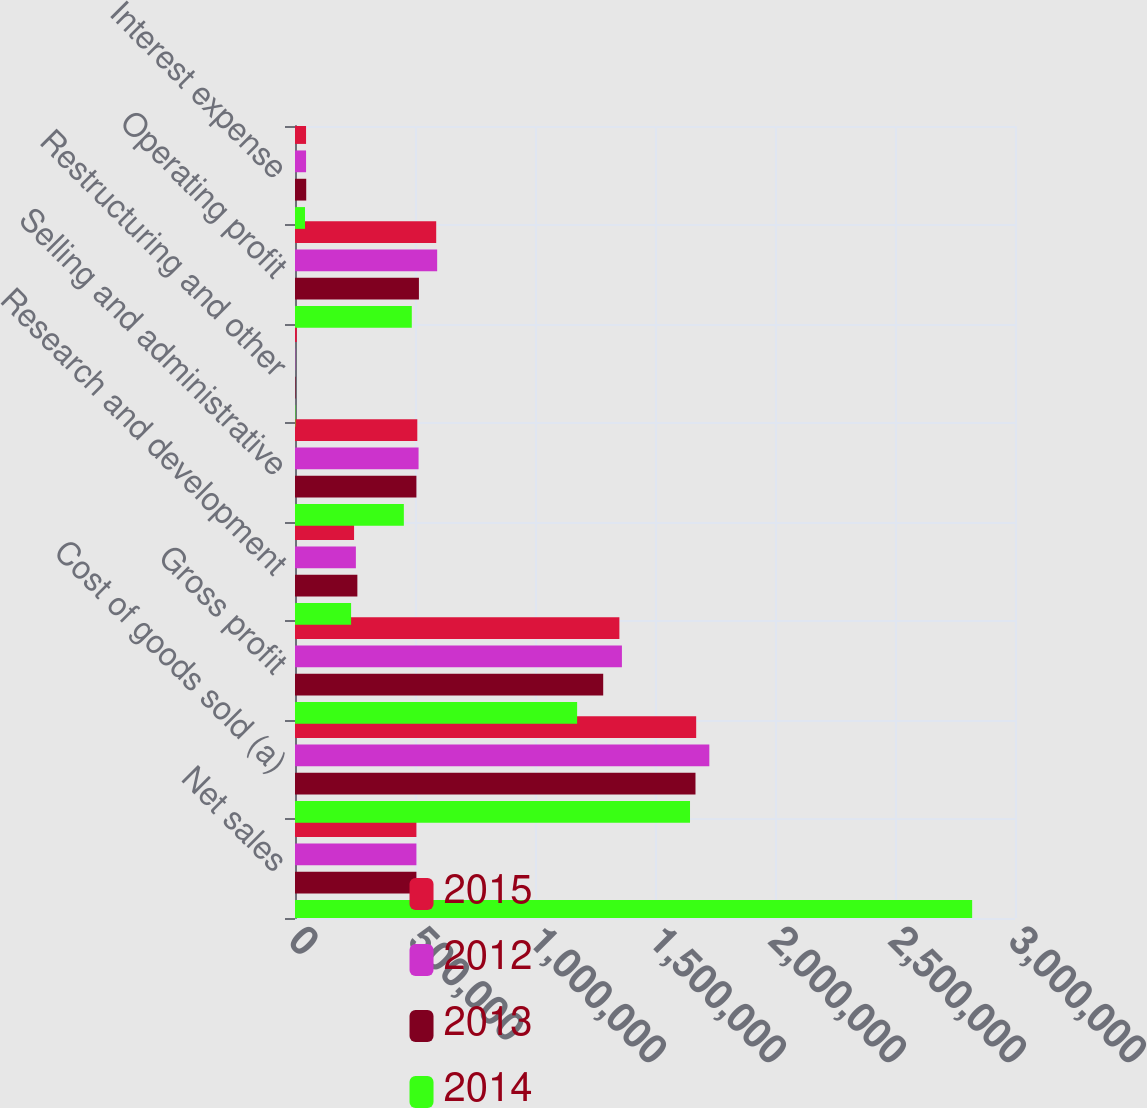<chart> <loc_0><loc_0><loc_500><loc_500><stacked_bar_chart><ecel><fcel>Net sales<fcel>Cost of goods sold (a)<fcel>Gross profit<fcel>Research and development<fcel>Selling and administrative<fcel>Restructuring and other<fcel>Operating profit<fcel>Interest expense<nl><fcel>2015<fcel>505877<fcel>1.67159e+06<fcel>1.3516e+06<fcel>246101<fcel>509557<fcel>7594<fcel>588347<fcel>46062<nl><fcel>2012<fcel>505877<fcel>1.72638e+06<fcel>1.36215e+06<fcel>253640<fcel>514891<fcel>1298<fcel>592321<fcel>46067<nl><fcel>2013<fcel>505877<fcel>1.66869e+06<fcel>1.2842e+06<fcel>259838<fcel>505877<fcel>2151<fcel>516339<fcel>46767<nl><fcel>2014<fcel>2.82145e+06<fcel>1.64591e+06<fcel>1.17553e+06<fcel>233713<fcel>453535<fcel>1668<fcel>486618<fcel>41753<nl></chart> 